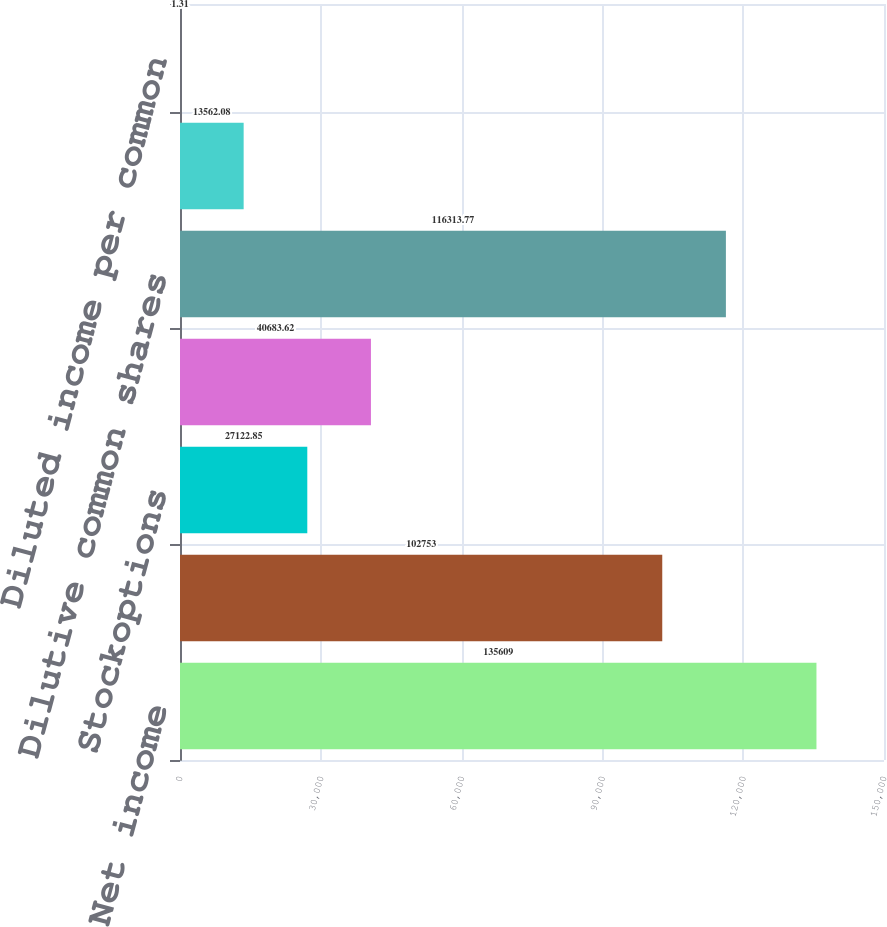Convert chart to OTSL. <chart><loc_0><loc_0><loc_500><loc_500><bar_chart><fcel>Net income<fcel>Basic common shares<fcel>Stockoptions<fcel>Unvested restricted stock<fcel>Dilutive common shares<fcel>Basic income per common share<fcel>Diluted income per common<nl><fcel>135609<fcel>102753<fcel>27122.8<fcel>40683.6<fcel>116314<fcel>13562.1<fcel>1.31<nl></chart> 